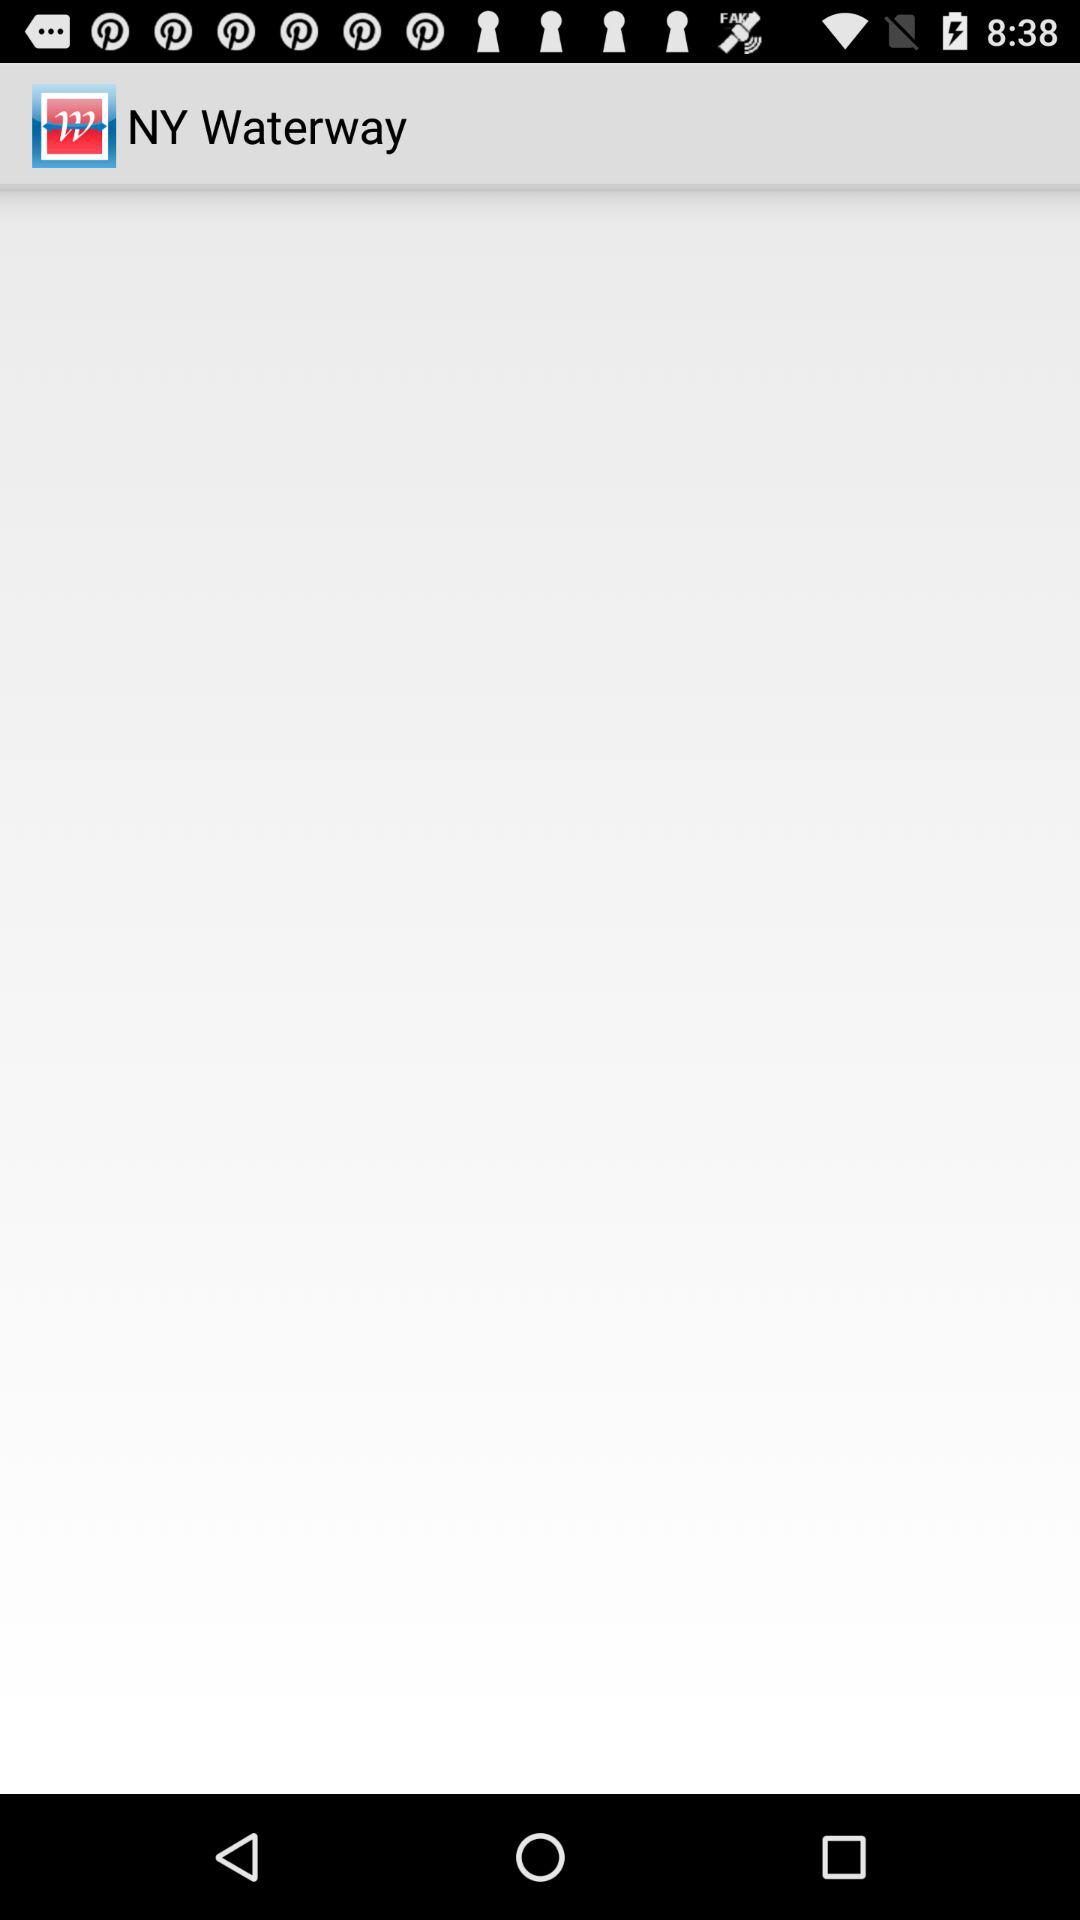What is the application name? The application name is "NY Waterway". 